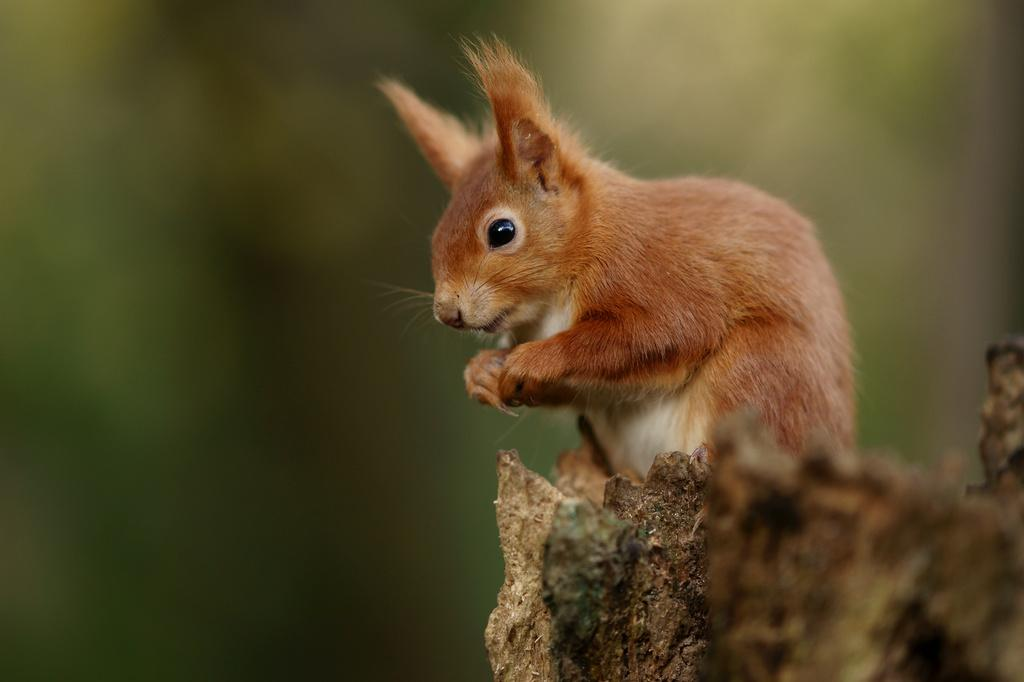What type of animal is in the image? There is a brown squirrel in the image. Where is the squirrel located? The squirrel is standing on the bark of a tree. Can you describe the background of the image? The background of the image is blurry. What is the squirrel doing in the office in the image? There is no office present in the image; it features a brown squirrel standing on the bark of a tree. 